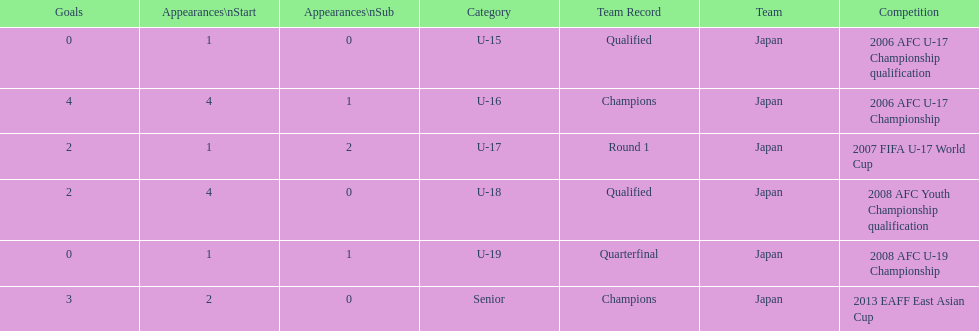What competitive event did japan take part in 2013? 2013 EAFF East Asian Cup. 